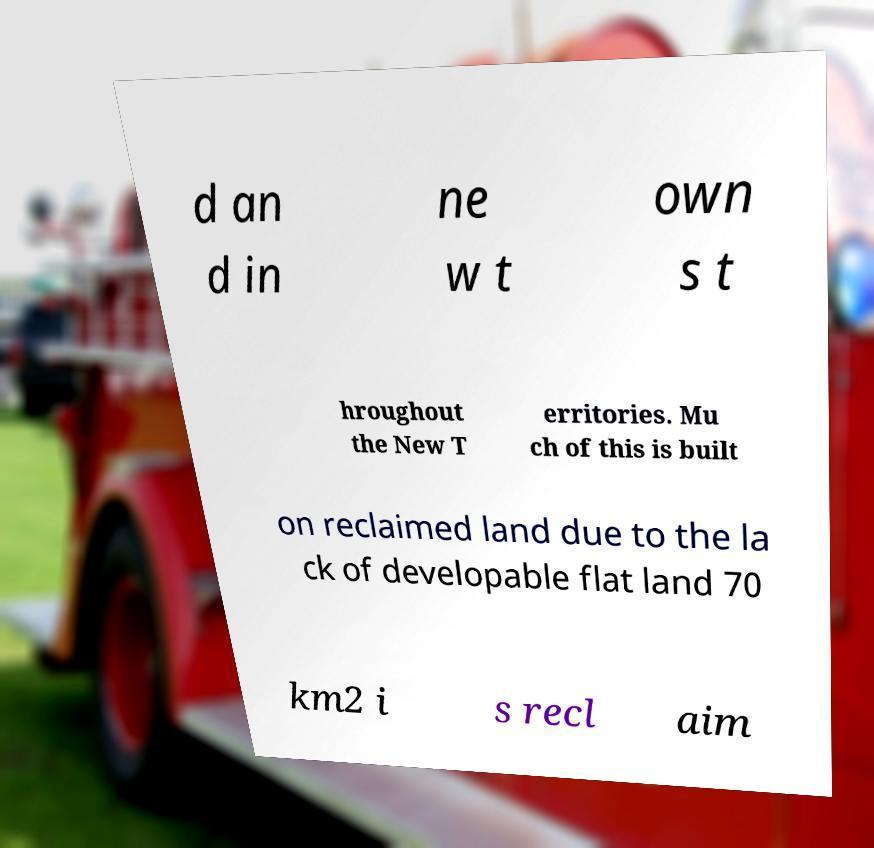I need the written content from this picture converted into text. Can you do that? d an d in ne w t own s t hroughout the New T erritories. Mu ch of this is built on reclaimed land due to the la ck of developable flat land 70 km2 i s recl aim 